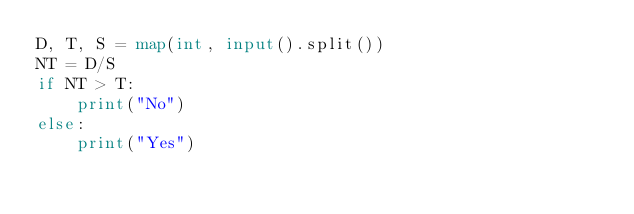<code> <loc_0><loc_0><loc_500><loc_500><_Python_>D, T, S = map(int, input().split())
NT = D/S
if NT > T:
    print("No")
else:
    print("Yes")</code> 